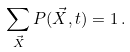Convert formula to latex. <formula><loc_0><loc_0><loc_500><loc_500>\sum _ { \vec { X } } P ( \vec { X } , t ) = 1 \, .</formula> 